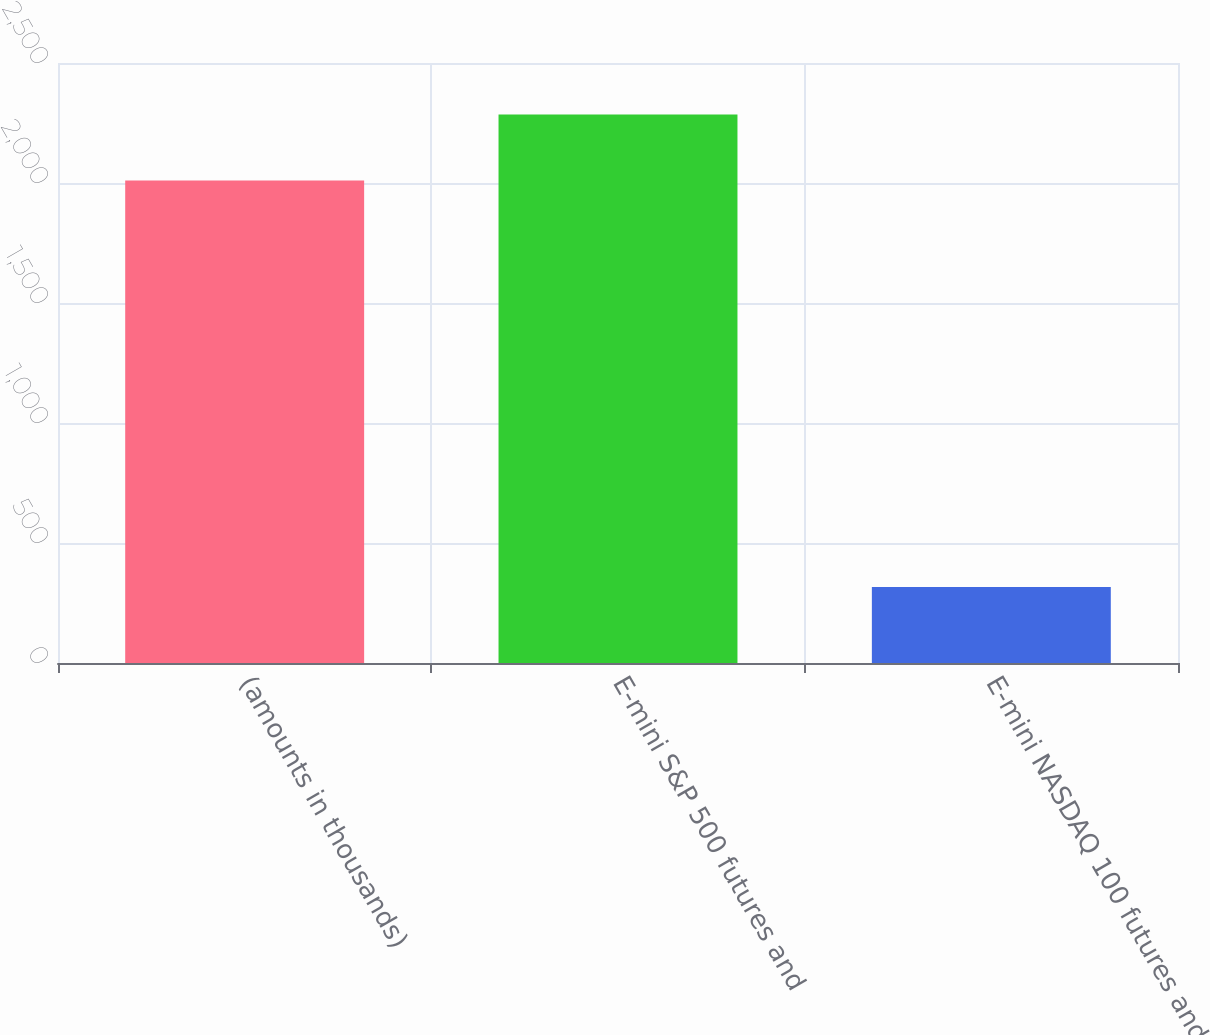Convert chart. <chart><loc_0><loc_0><loc_500><loc_500><bar_chart><fcel>(amounts in thousands)<fcel>E-mini S&P 500 futures and<fcel>E-mini NASDAQ 100 futures and<nl><fcel>2010<fcel>2285<fcel>317<nl></chart> 